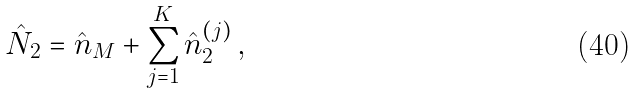<formula> <loc_0><loc_0><loc_500><loc_500>\hat { N } _ { 2 } = \hat { n } _ { M } + \sum _ { j = 1 } ^ { K } \hat { n } _ { 2 } ^ { ( j ) } \, ,</formula> 